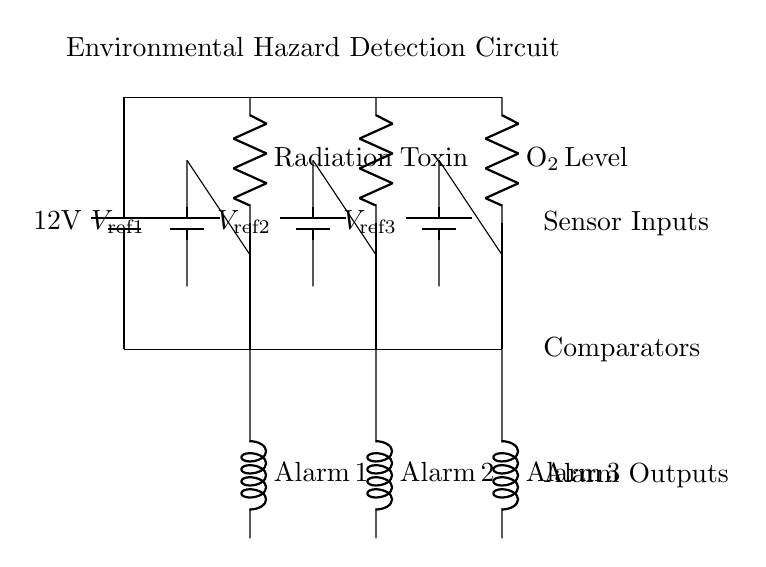What type of sensors are used in this circuit? The circuit includes three types of sensors: Radiation, Toxin, and O2 Level. These are clearly labeled within the diagram.
Answer: Radiation, Toxin, O2 Level What is the reference voltage used for the radiation sensor? The reference voltage for the radiation sensor is indicated as V ref1, located next to the radiation comparator, showing the corresponding battery supplying it.
Answer: V ref1 How many alarm outputs are present in this circuit? The circuit diagram has three alarm outputs, as represented by Alarm 1, Alarm 2, and Alarm 3, connected to their respective comparators.
Answer: 3 What is the role of the comparators in the circuit? The comparators compare the voltage from the sensors to their respective reference voltages. If the sensor voltage exceeds the reference voltage, it triggers the alarm output.
Answer: Comparison What is the function of the battery in this circuit? The battery provides a constant voltage supply to the entire circuit, specifically 12 volts, powering both the sensors and the comparators.
Answer: 12 volts In which order are the alarm outputs triggered based on the sensors? The output sequence corresponds to the sensors from left to right: Alarm 1 for radiation, Alarm 2 for toxin, and Alarm 3 for O2 level.
Answer: Left to right 